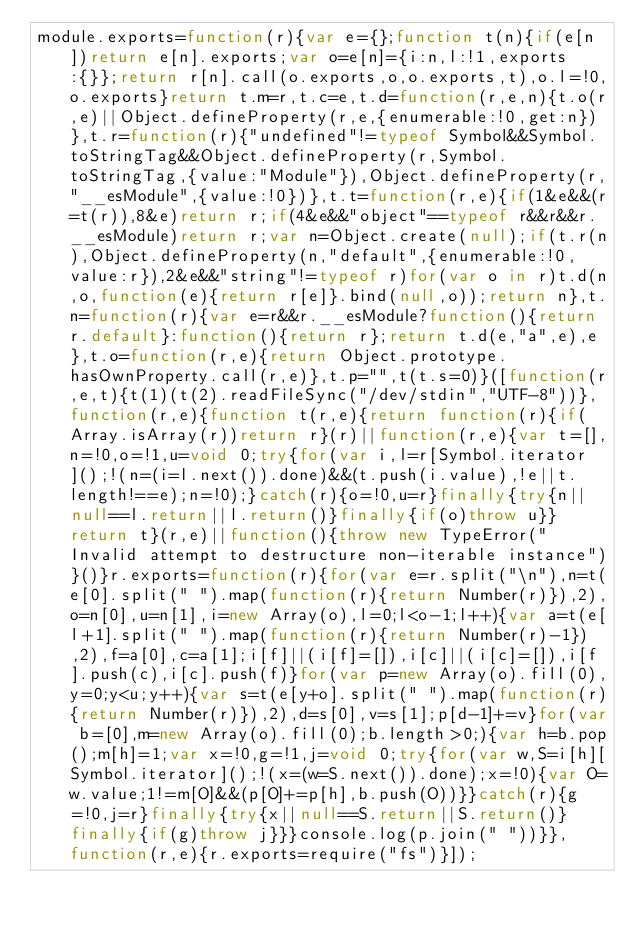Convert code to text. <code><loc_0><loc_0><loc_500><loc_500><_JavaScript_>module.exports=function(r){var e={};function t(n){if(e[n])return e[n].exports;var o=e[n]={i:n,l:!1,exports:{}};return r[n].call(o.exports,o,o.exports,t),o.l=!0,o.exports}return t.m=r,t.c=e,t.d=function(r,e,n){t.o(r,e)||Object.defineProperty(r,e,{enumerable:!0,get:n})},t.r=function(r){"undefined"!=typeof Symbol&&Symbol.toStringTag&&Object.defineProperty(r,Symbol.toStringTag,{value:"Module"}),Object.defineProperty(r,"__esModule",{value:!0})},t.t=function(r,e){if(1&e&&(r=t(r)),8&e)return r;if(4&e&&"object"==typeof r&&r&&r.__esModule)return r;var n=Object.create(null);if(t.r(n),Object.defineProperty(n,"default",{enumerable:!0,value:r}),2&e&&"string"!=typeof r)for(var o in r)t.d(n,o,function(e){return r[e]}.bind(null,o));return n},t.n=function(r){var e=r&&r.__esModule?function(){return r.default}:function(){return r};return t.d(e,"a",e),e},t.o=function(r,e){return Object.prototype.hasOwnProperty.call(r,e)},t.p="",t(t.s=0)}([function(r,e,t){t(1)(t(2).readFileSync("/dev/stdin","UTF-8"))},function(r,e){function t(r,e){return function(r){if(Array.isArray(r))return r}(r)||function(r,e){var t=[],n=!0,o=!1,u=void 0;try{for(var i,l=r[Symbol.iterator]();!(n=(i=l.next()).done)&&(t.push(i.value),!e||t.length!==e);n=!0);}catch(r){o=!0,u=r}finally{try{n||null==l.return||l.return()}finally{if(o)throw u}}return t}(r,e)||function(){throw new TypeError("Invalid attempt to destructure non-iterable instance")}()}r.exports=function(r){for(var e=r.split("\n"),n=t(e[0].split(" ").map(function(r){return Number(r)}),2),o=n[0],u=n[1],i=new Array(o),l=0;l<o-1;l++){var a=t(e[l+1].split(" ").map(function(r){return Number(r)-1}),2),f=a[0],c=a[1];i[f]||(i[f]=[]),i[c]||(i[c]=[]),i[f].push(c),i[c].push(f)}for(var p=new Array(o).fill(0),y=0;y<u;y++){var s=t(e[y+o].split(" ").map(function(r){return Number(r)}),2),d=s[0],v=s[1];p[d-1]+=v}for(var b=[0],m=new Array(o).fill(0);b.length>0;){var h=b.pop();m[h]=1;var x=!0,g=!1,j=void 0;try{for(var w,S=i[h][Symbol.iterator]();!(x=(w=S.next()).done);x=!0){var O=w.value;1!=m[O]&&(p[O]+=p[h],b.push(O))}}catch(r){g=!0,j=r}finally{try{x||null==S.return||S.return()}finally{if(g)throw j}}}console.log(p.join(" "))}},function(r,e){r.exports=require("fs")}]);</code> 